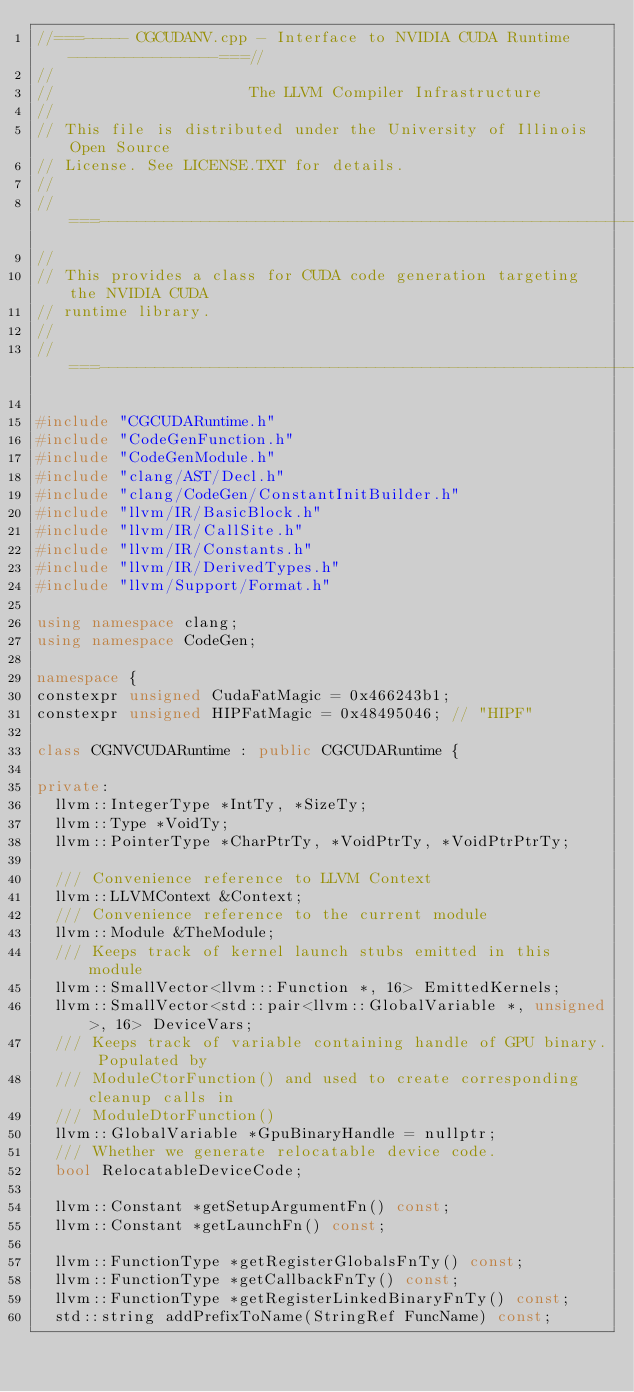Convert code to text. <code><loc_0><loc_0><loc_500><loc_500><_C++_>//===----- CGCUDANV.cpp - Interface to NVIDIA CUDA Runtime ----------------===//
//
//                     The LLVM Compiler Infrastructure
//
// This file is distributed under the University of Illinois Open Source
// License. See LICENSE.TXT for details.
//
//===----------------------------------------------------------------------===//
//
// This provides a class for CUDA code generation targeting the NVIDIA CUDA
// runtime library.
//
//===----------------------------------------------------------------------===//

#include "CGCUDARuntime.h"
#include "CodeGenFunction.h"
#include "CodeGenModule.h"
#include "clang/AST/Decl.h"
#include "clang/CodeGen/ConstantInitBuilder.h"
#include "llvm/IR/BasicBlock.h"
#include "llvm/IR/CallSite.h"
#include "llvm/IR/Constants.h"
#include "llvm/IR/DerivedTypes.h"
#include "llvm/Support/Format.h"

using namespace clang;
using namespace CodeGen;

namespace {
constexpr unsigned CudaFatMagic = 0x466243b1;
constexpr unsigned HIPFatMagic = 0x48495046; // "HIPF"

class CGNVCUDARuntime : public CGCUDARuntime {

private:
  llvm::IntegerType *IntTy, *SizeTy;
  llvm::Type *VoidTy;
  llvm::PointerType *CharPtrTy, *VoidPtrTy, *VoidPtrPtrTy;

  /// Convenience reference to LLVM Context
  llvm::LLVMContext &Context;
  /// Convenience reference to the current module
  llvm::Module &TheModule;
  /// Keeps track of kernel launch stubs emitted in this module
  llvm::SmallVector<llvm::Function *, 16> EmittedKernels;
  llvm::SmallVector<std::pair<llvm::GlobalVariable *, unsigned>, 16> DeviceVars;
  /// Keeps track of variable containing handle of GPU binary. Populated by
  /// ModuleCtorFunction() and used to create corresponding cleanup calls in
  /// ModuleDtorFunction()
  llvm::GlobalVariable *GpuBinaryHandle = nullptr;
  /// Whether we generate relocatable device code.
  bool RelocatableDeviceCode;

  llvm::Constant *getSetupArgumentFn() const;
  llvm::Constant *getLaunchFn() const;

  llvm::FunctionType *getRegisterGlobalsFnTy() const;
  llvm::FunctionType *getCallbackFnTy() const;
  llvm::FunctionType *getRegisterLinkedBinaryFnTy() const;
  std::string addPrefixToName(StringRef FuncName) const;</code> 